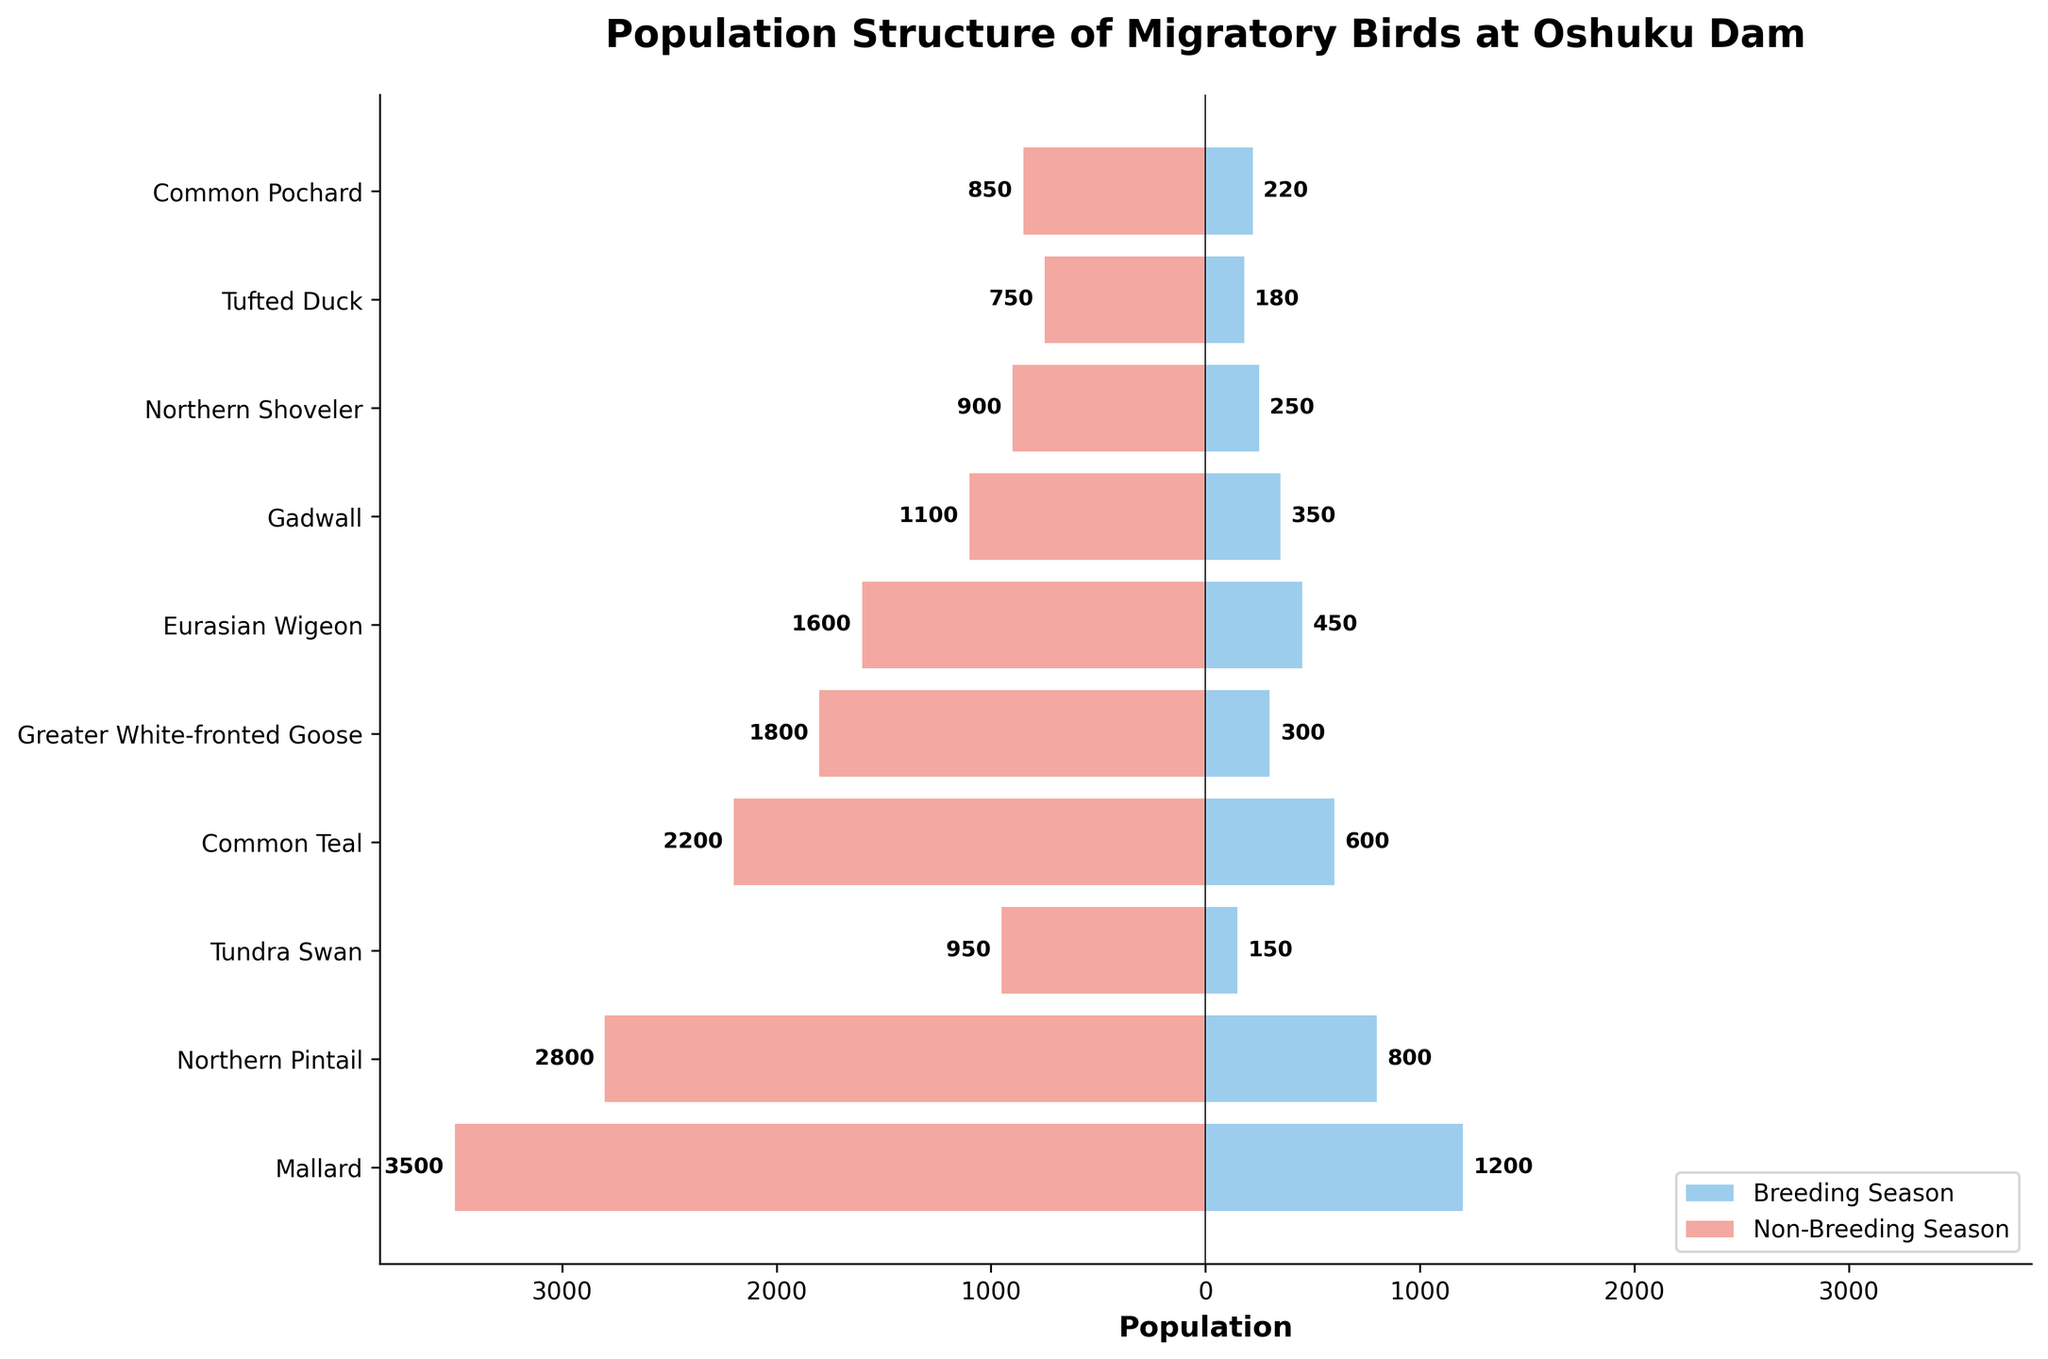Which species has the highest population during the non-breeding season? Observing the bars on the left side of the chart (colored in red for the non-breeding season), the Mallard has the longest length, indicating it has the highest population.
Answer: Mallard What is the total population of the Common Teal in both seasons combined? Adding the values from both seasons for the Common Teal: Breeding season (600) + Non-breeding season (2200) = 2800.
Answer: 2800 Which species has a greater population in the breeding season compared to the non-breeding season? Comparing the bar lengths on the right side of the chart (blue) with the corresponding left side (red), none of the species have a longer blue bar compared to the red bar indicating no species has a greater population in the breeding season compared to the non-breeding season.
Answer: None What is the difference in the population of Mallard between the breeding and non-breeding seasons? Subtract the breeding population from the non-breeding population for Mallard: 3500 (Non-breeding) - 1200 (Breeding) = 2300.
Answer: 2300 Which species has the smallest population during the breeding season? Observing the shortest bar on the right side of the chart (blue), the Tundra Swan has the smallest population for the breeding season at 150.
Answer: Tundra Swan How many species have a breeding season population of more than 400? Counting the species whose blue bars are longer than the 400 mark: Mallard (1200), Northern Pintail (800), Common Teal (600), and Eurasian Wigeon (450) make 4 species.
Answer: 4 Is the population of the Tundra Swan more than the Northern Shoveler during the non-breeding season? Comparing the red bars for both species, Tundra Swan (950) is greater than Northern Shoveler (900).
Answer: Yes How much more populated is the Northern Pintail in the non-breeding season compared to the breeding season? Subtract the breeding population from the non-breeding population for Northern Pintail: 2800 (Non-breeding) - 800 (Breeding) = 2000.
Answer: 2000 What is the average population of species during the breeding season? Adding the populations for all species during the breeding season and dividing by the number of species: (1200 + 800 + 150 + 600 + 300 + 450 + 350 + 250 + 180 + 220) / 10 = 4500 / 10 = 450.
Answer: 450 Which species shows the greatest proportional increase in population from breeding to non-breeding season? Calculating the proportional increase for each species: (Non-breeding - Breeding) / Breeding, then finding the max:
- Mallard: (3500 - 1200) / 1200 = 1.92
- Northern Pintail: (2800 - 800) / 800 = 2.5
- Tundra Swan: (950 - 150) / 150 = 5.33
- Common Teal: (2200 - 600) / 600 = 2.67
- Greater White-fronted Goose: (1800 - 300) / 300 = 5
- Eurasian Wigeon: (1600 - 450) / 450 = 2.56
- Gadwall: (1100 - 350) / 350 = 2.14
- Northern Shoveler: (900 - 250) / 250 = 2.6
- Tufted Duck: (750 - 180) / 180 = 3.17
- Common Pochard: (850 - 220) / 220 = 2.86
Tundra Swan has the greatest proportional increase at 5.33.
Answer: Tundra Swan 